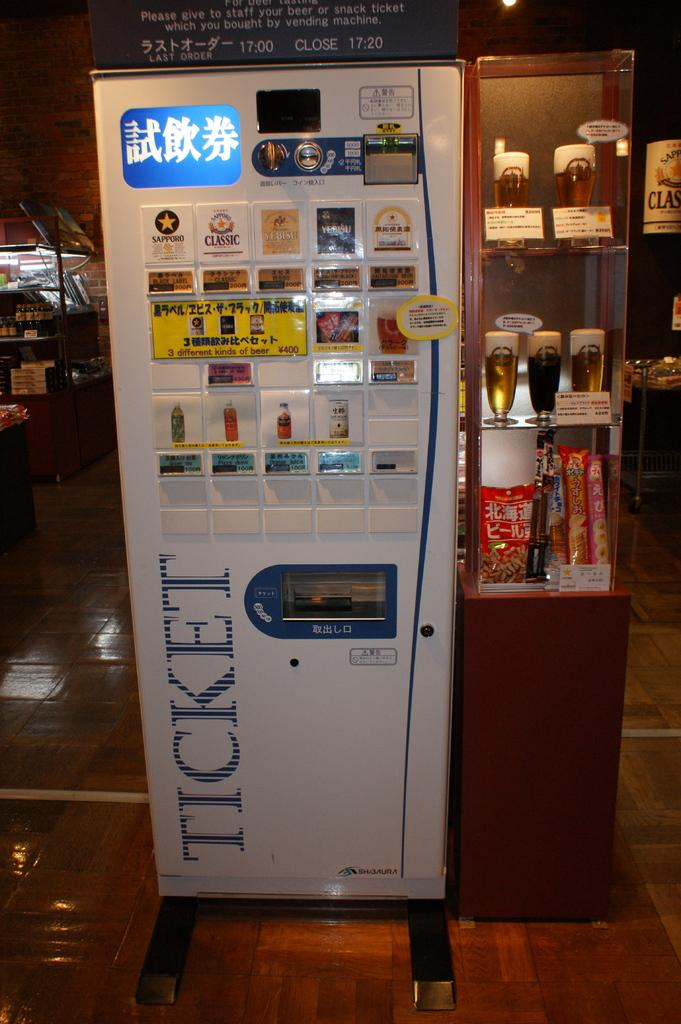<image>
Offer a succinct explanation of the picture presented. A ticketing machine selling a ticket for Sapporo beer among other drinks. 